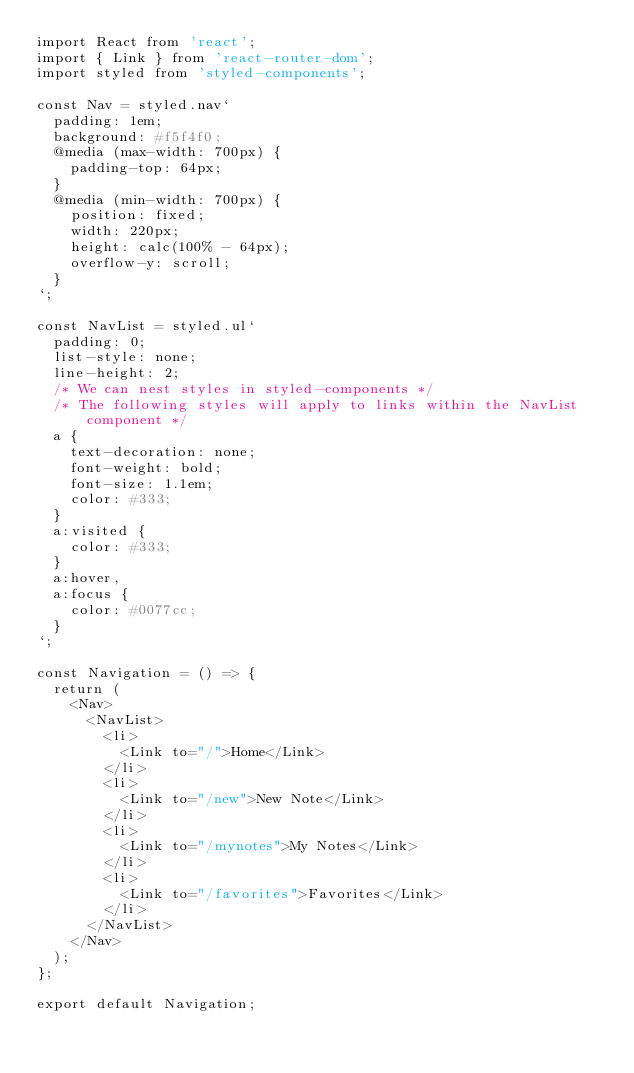Convert code to text. <code><loc_0><loc_0><loc_500><loc_500><_JavaScript_>import React from 'react';
import { Link } from 'react-router-dom';
import styled from 'styled-components';

const Nav = styled.nav`
  padding: 1em;
  background: #f5f4f0;
  @media (max-width: 700px) {
    padding-top: 64px;
  }
  @media (min-width: 700px) {
    position: fixed;
    width: 220px;
    height: calc(100% - 64px);
    overflow-y: scroll;
  }
`;

const NavList = styled.ul`
  padding: 0;
  list-style: none;
  line-height: 2;
  /* We can nest styles in styled-components */
  /* The following styles will apply to links within the NavList component */
  a {
    text-decoration: none;
    font-weight: bold;
    font-size: 1.1em;
    color: #333;
  }
  a:visited {
    color: #333;
  }
  a:hover,
  a:focus {
    color: #0077cc;
  }
`;

const Navigation = () => {
  return (
    <Nav>
      <NavList>
        <li>
          <Link to="/">Home</Link>
        </li>
        <li>
          <Link to="/new">New Note</Link>
        </li>
        <li>
          <Link to="/mynotes">My Notes</Link>
        </li>
        <li>
          <Link to="/favorites">Favorites</Link>
        </li>
      </NavList>
    </Nav>
  );
};

export default Navigation;
</code> 